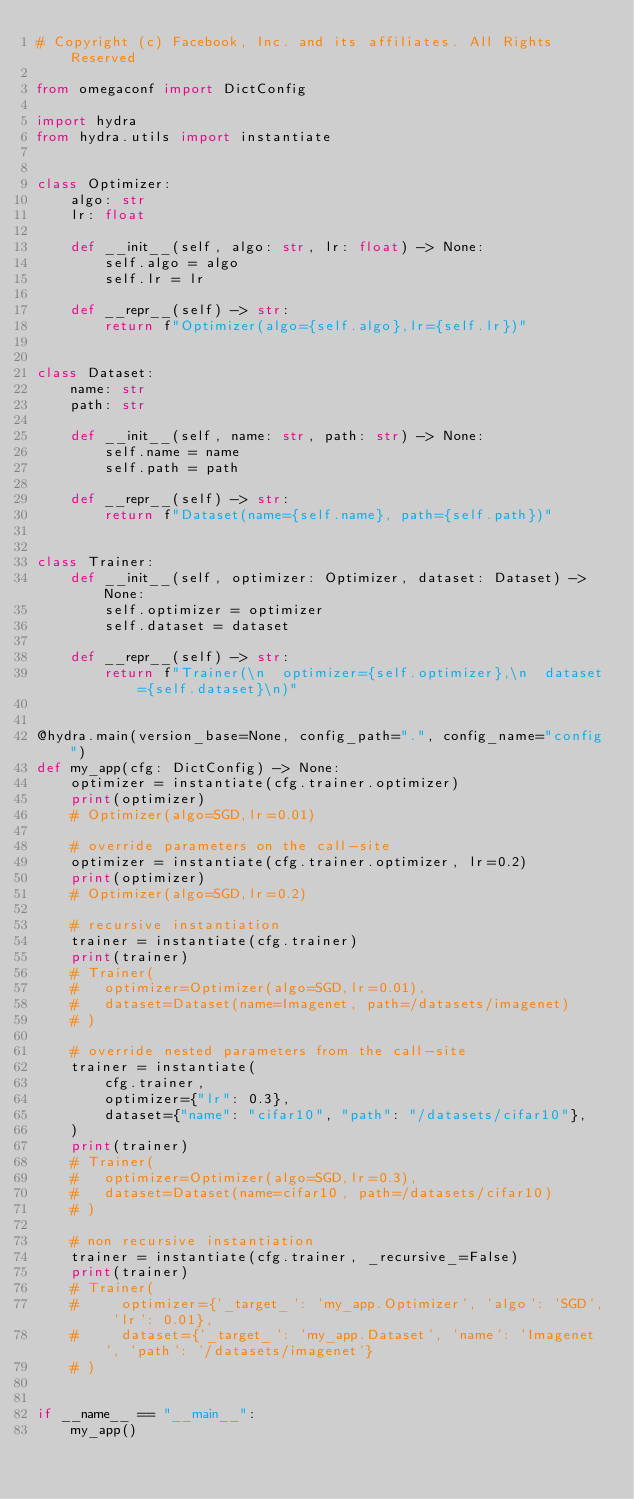Convert code to text. <code><loc_0><loc_0><loc_500><loc_500><_Python_># Copyright (c) Facebook, Inc. and its affiliates. All Rights Reserved

from omegaconf import DictConfig

import hydra
from hydra.utils import instantiate


class Optimizer:
    algo: str
    lr: float

    def __init__(self, algo: str, lr: float) -> None:
        self.algo = algo
        self.lr = lr

    def __repr__(self) -> str:
        return f"Optimizer(algo={self.algo},lr={self.lr})"


class Dataset:
    name: str
    path: str

    def __init__(self, name: str, path: str) -> None:
        self.name = name
        self.path = path

    def __repr__(self) -> str:
        return f"Dataset(name={self.name}, path={self.path})"


class Trainer:
    def __init__(self, optimizer: Optimizer, dataset: Dataset) -> None:
        self.optimizer = optimizer
        self.dataset = dataset

    def __repr__(self) -> str:
        return f"Trainer(\n  optimizer={self.optimizer},\n  dataset={self.dataset}\n)"


@hydra.main(version_base=None, config_path=".", config_name="config")
def my_app(cfg: DictConfig) -> None:
    optimizer = instantiate(cfg.trainer.optimizer)
    print(optimizer)
    # Optimizer(algo=SGD,lr=0.01)

    # override parameters on the call-site
    optimizer = instantiate(cfg.trainer.optimizer, lr=0.2)
    print(optimizer)
    # Optimizer(algo=SGD,lr=0.2)

    # recursive instantiation
    trainer = instantiate(cfg.trainer)
    print(trainer)
    # Trainer(
    #   optimizer=Optimizer(algo=SGD,lr=0.01),
    #   dataset=Dataset(name=Imagenet, path=/datasets/imagenet)
    # )

    # override nested parameters from the call-site
    trainer = instantiate(
        cfg.trainer,
        optimizer={"lr": 0.3},
        dataset={"name": "cifar10", "path": "/datasets/cifar10"},
    )
    print(trainer)
    # Trainer(
    #   optimizer=Optimizer(algo=SGD,lr=0.3),
    #   dataset=Dataset(name=cifar10, path=/datasets/cifar10)
    # )

    # non recursive instantiation
    trainer = instantiate(cfg.trainer, _recursive_=False)
    print(trainer)
    # Trainer(
    #     optimizer={'_target_': 'my_app.Optimizer', 'algo': 'SGD', 'lr': 0.01},
    #     dataset={'_target_': 'my_app.Dataset', 'name': 'Imagenet', 'path': '/datasets/imagenet'}
    # )


if __name__ == "__main__":
    my_app()
</code> 